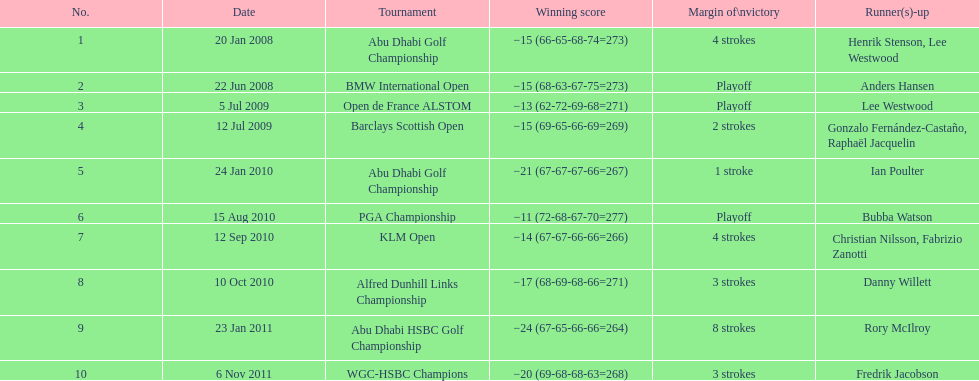How many competitions has he won by 3 or more strokes? 5. 